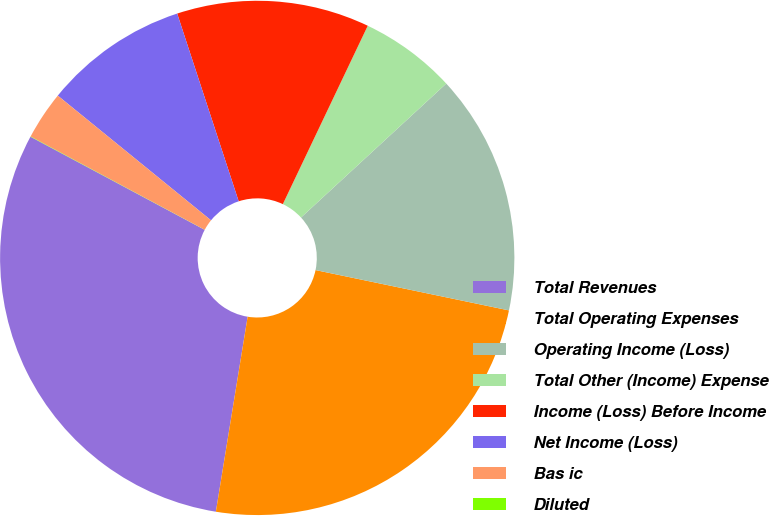<chart> <loc_0><loc_0><loc_500><loc_500><pie_chart><fcel>Total Revenues<fcel>Total Operating Expenses<fcel>Operating Income (Loss)<fcel>Total Other (Income) Expense<fcel>Income (Loss) Before Income<fcel>Net Income (Loss)<fcel>Bas ic<fcel>Diluted<nl><fcel>30.24%<fcel>24.3%<fcel>15.13%<fcel>6.07%<fcel>12.11%<fcel>9.09%<fcel>3.04%<fcel>0.02%<nl></chart> 